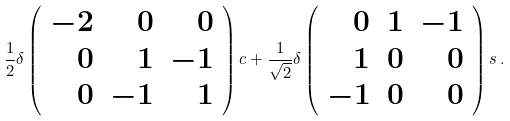Convert formula to latex. <formula><loc_0><loc_0><loc_500><loc_500>\frac { 1 } { 2 } \delta \left ( \begin{array} { r r r } - 2 & 0 & 0 \\ 0 & 1 & - 1 \\ 0 & - 1 & 1 \end{array} \right ) c + \frac { 1 } { \sqrt { 2 } } \delta \left ( \begin{array} { r r r } 0 & 1 & - 1 \\ 1 & 0 & 0 \\ - 1 & 0 & 0 \end{array} \right ) s \, .</formula> 